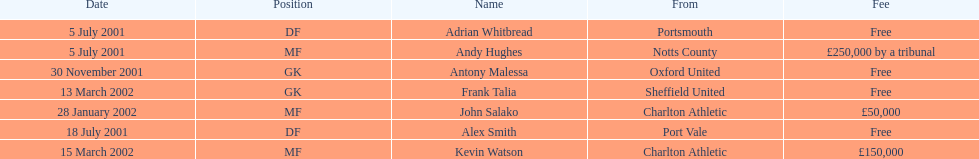What was the transfer fee to transfer kevin watson? £150,000. Help me parse the entirety of this table. {'header': ['Date', 'Position', 'Name', 'From', 'Fee'], 'rows': [['5 July 2001', 'DF', 'Adrian Whitbread', 'Portsmouth', 'Free'], ['5 July 2001', 'MF', 'Andy Hughes', 'Notts County', '£250,000 by a tribunal'], ['30 November 2001', 'GK', 'Antony Malessa', 'Oxford United', 'Free'], ['13 March 2002', 'GK', 'Frank Talia', 'Sheffield United', 'Free'], ['28 January 2002', 'MF', 'John Salako', 'Charlton Athletic', '£50,000'], ['18 July 2001', 'DF', 'Alex Smith', 'Port Vale', 'Free'], ['15 March 2002', 'MF', 'Kevin Watson', 'Charlton Athletic', '£150,000']]} 